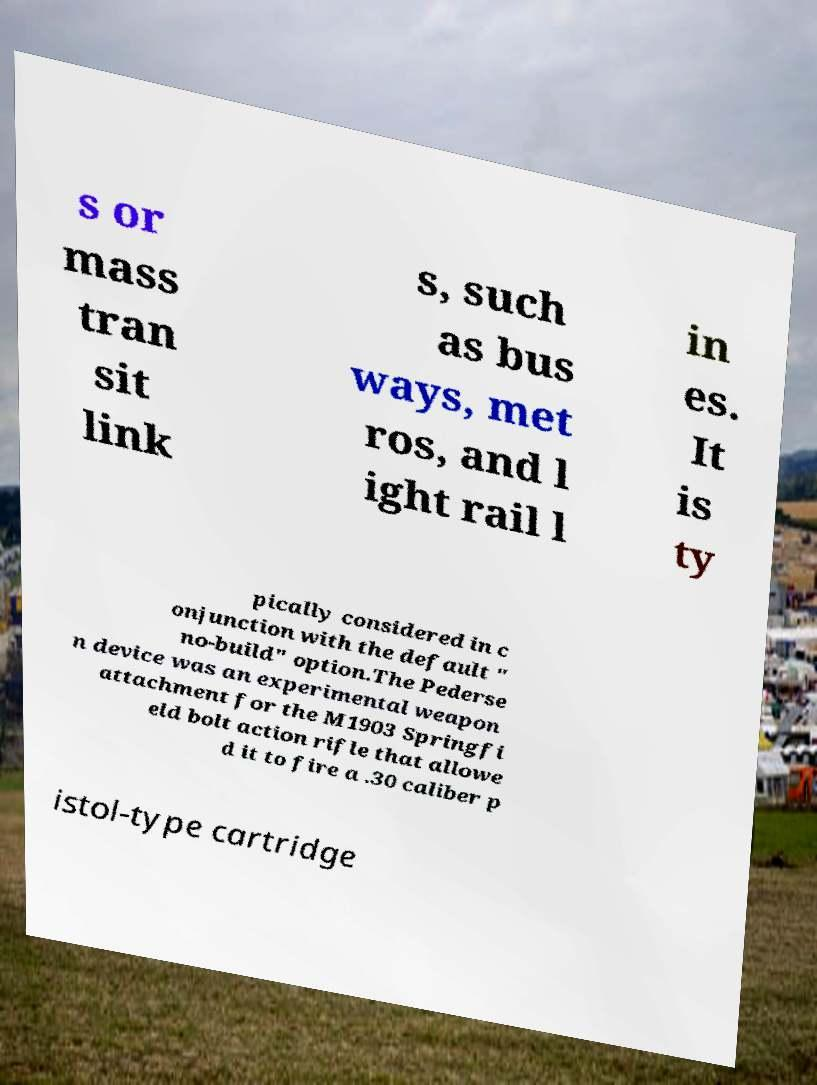Please identify and transcribe the text found in this image. s or mass tran sit link s, such as bus ways, met ros, and l ight rail l in es. It is ty pically considered in c onjunction with the default " no-build" option.The Pederse n device was an experimental weapon attachment for the M1903 Springfi eld bolt action rifle that allowe d it to fire a .30 caliber p istol-type cartridge 